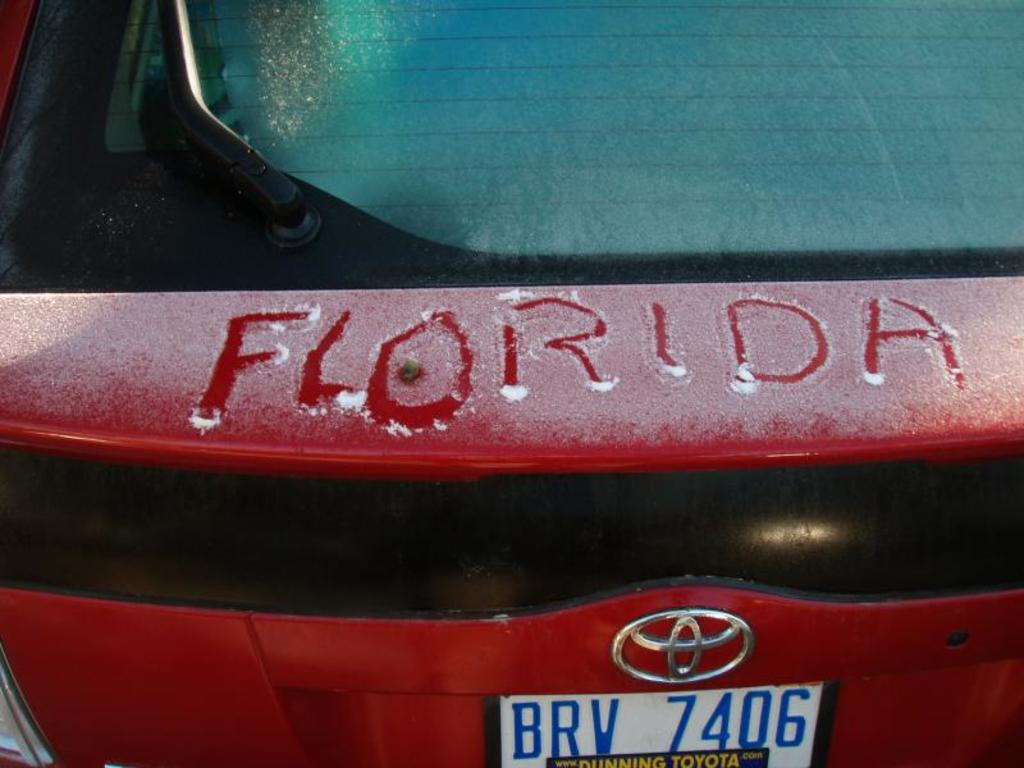What do you think is going on in this snapshot? This snapshot beautifully captures a wintery scene on a car's rear, featuring a chilly morning with frost over the red Toyota. Someone has whimsically written 'Florida' across the trunk, perhaps dreaming of warmer, sunnier shores as they face a cold day. The license plate, 'BRV 7406,' helps identify this vehicle uniquely, adding a touch of realism to the scene. This image could evoke a sense of longing or humor, depending on the viewer's perspective, merging everyday life with dreams of distant places. 